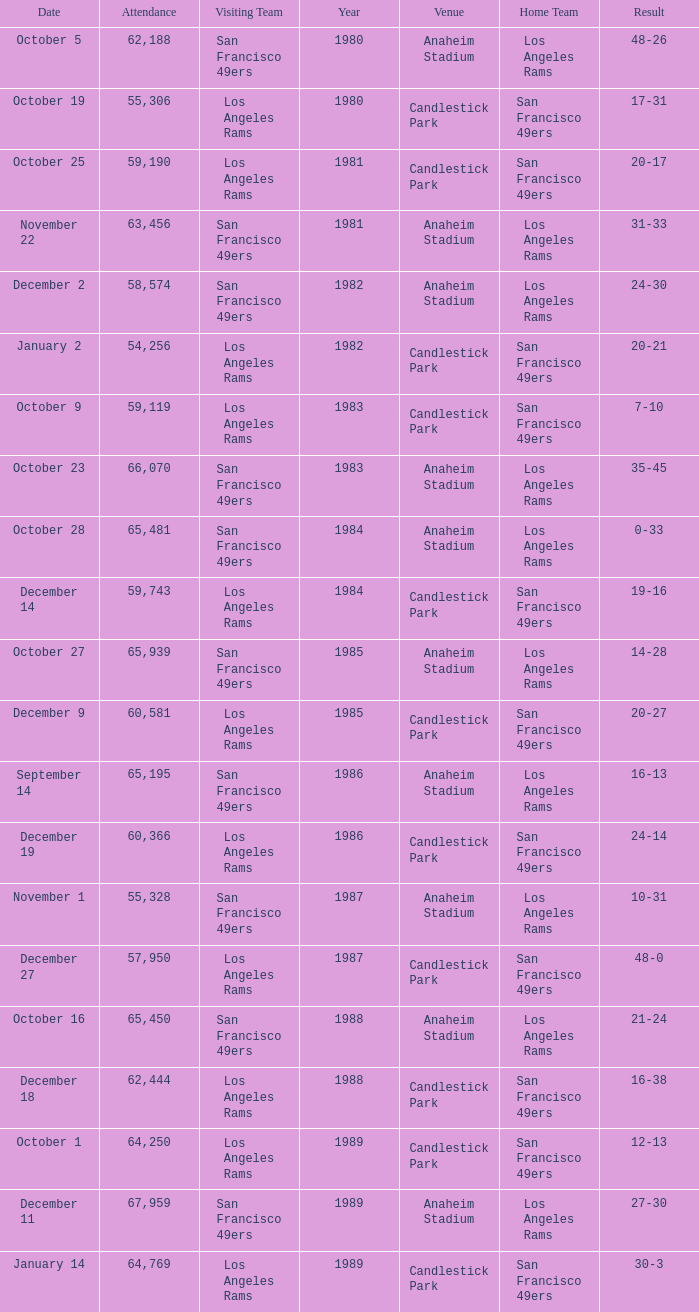Give me the full table as a dictionary. {'header': ['Date', 'Attendance', 'Visiting Team', 'Year', 'Venue', 'Home Team', 'Result'], 'rows': [['October 5', '62,188', 'San Francisco 49ers', '1980', 'Anaheim Stadium', 'Los Angeles Rams', '48-26'], ['October 19', '55,306', 'Los Angeles Rams', '1980', 'Candlestick Park', 'San Francisco 49ers', '17-31'], ['October 25', '59,190', 'Los Angeles Rams', '1981', 'Candlestick Park', 'San Francisco 49ers', '20-17'], ['November 22', '63,456', 'San Francisco 49ers', '1981', 'Anaheim Stadium', 'Los Angeles Rams', '31-33'], ['December 2', '58,574', 'San Francisco 49ers', '1982', 'Anaheim Stadium', 'Los Angeles Rams', '24-30'], ['January 2', '54,256', 'Los Angeles Rams', '1982', 'Candlestick Park', 'San Francisco 49ers', '20-21'], ['October 9', '59,119', 'Los Angeles Rams', '1983', 'Candlestick Park', 'San Francisco 49ers', '7-10'], ['October 23', '66,070', 'San Francisco 49ers', '1983', 'Anaheim Stadium', 'Los Angeles Rams', '35-45'], ['October 28', '65,481', 'San Francisco 49ers', '1984', 'Anaheim Stadium', 'Los Angeles Rams', '0-33'], ['December 14', '59,743', 'Los Angeles Rams', '1984', 'Candlestick Park', 'San Francisco 49ers', '19-16'], ['October 27', '65,939', 'San Francisco 49ers', '1985', 'Anaheim Stadium', 'Los Angeles Rams', '14-28'], ['December 9', '60,581', 'Los Angeles Rams', '1985', 'Candlestick Park', 'San Francisco 49ers', '20-27'], ['September 14', '65,195', 'San Francisco 49ers', '1986', 'Anaheim Stadium', 'Los Angeles Rams', '16-13'], ['December 19', '60,366', 'Los Angeles Rams', '1986', 'Candlestick Park', 'San Francisco 49ers', '24-14'], ['November 1', '55,328', 'San Francisco 49ers', '1987', 'Anaheim Stadium', 'Los Angeles Rams', '10-31'], ['December 27', '57,950', 'Los Angeles Rams', '1987', 'Candlestick Park', 'San Francisco 49ers', '48-0'], ['October 16', '65,450', 'San Francisco 49ers', '1988', 'Anaheim Stadium', 'Los Angeles Rams', '21-24'], ['December 18', '62,444', 'Los Angeles Rams', '1988', 'Candlestick Park', 'San Francisco 49ers', '16-38'], ['October 1', '64,250', 'Los Angeles Rams', '1989', 'Candlestick Park', 'San Francisco 49ers', '12-13'], ['December 11', '67,959', 'San Francisco 49ers', '1989', 'Anaheim Stadium', 'Los Angeles Rams', '27-30'], ['January 14', '64,769', 'Los Angeles Rams', '1989', 'Candlestick Park', 'San Francisco 49ers', '30-3']]} What's the total attendance at anaheim stadium after 1983 when the result is 14-28? 1.0. 